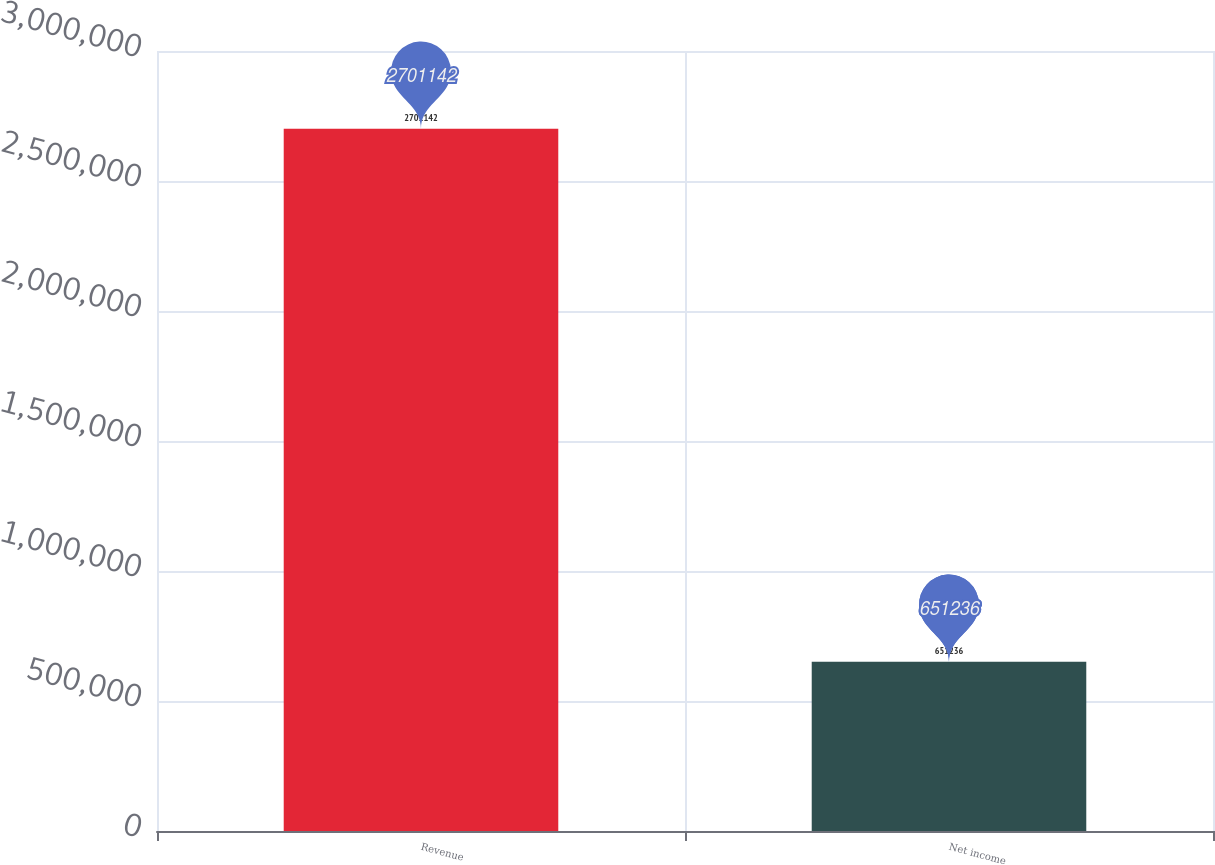Convert chart. <chart><loc_0><loc_0><loc_500><loc_500><bar_chart><fcel>Revenue<fcel>Net income<nl><fcel>2.70114e+06<fcel>651236<nl></chart> 